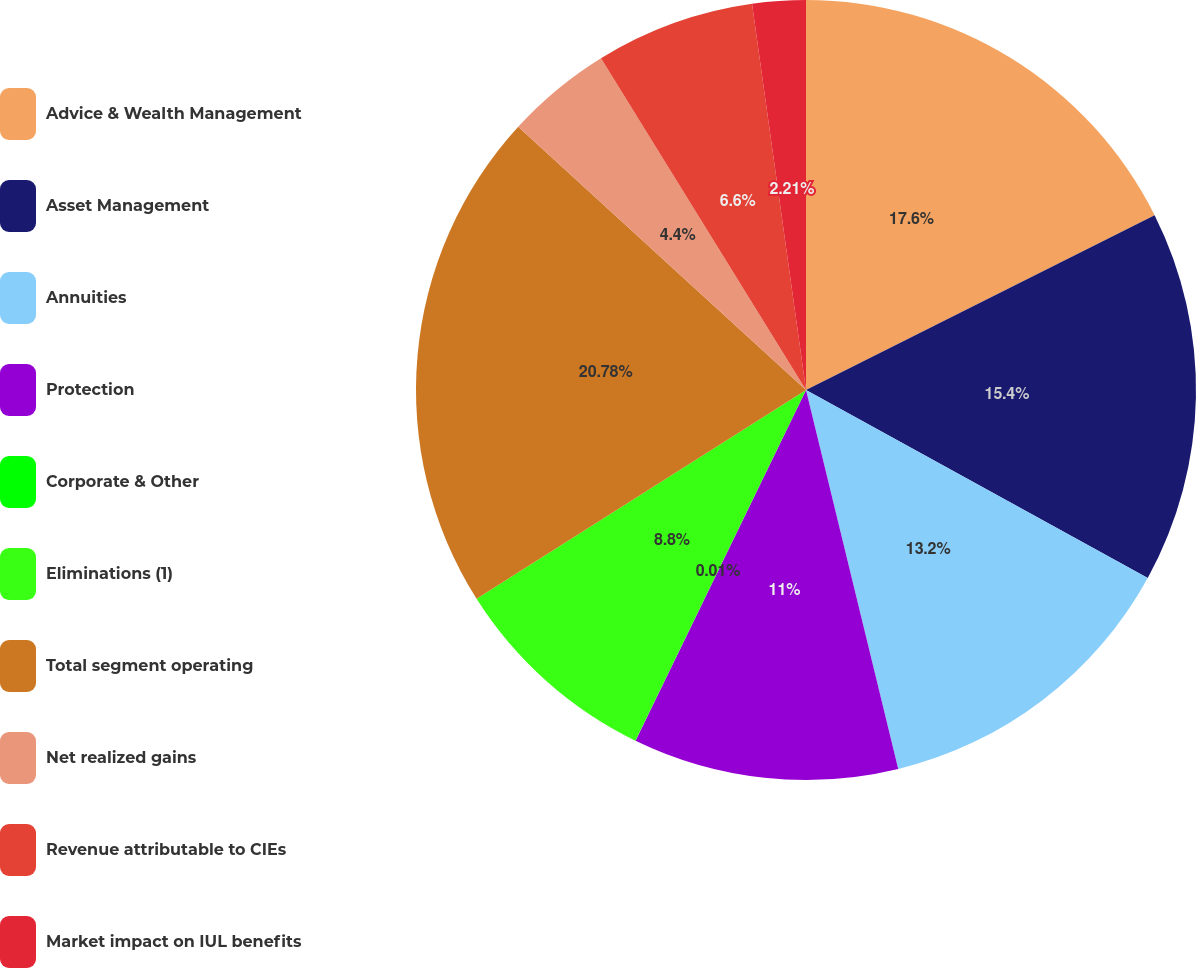Convert chart. <chart><loc_0><loc_0><loc_500><loc_500><pie_chart><fcel>Advice & Wealth Management<fcel>Asset Management<fcel>Annuities<fcel>Protection<fcel>Corporate & Other<fcel>Eliminations (1)<fcel>Total segment operating<fcel>Net realized gains<fcel>Revenue attributable to CIEs<fcel>Market impact on IUL benefits<nl><fcel>17.6%<fcel>15.4%<fcel>13.2%<fcel>11.0%<fcel>0.01%<fcel>8.8%<fcel>20.78%<fcel>4.4%<fcel>6.6%<fcel>2.21%<nl></chart> 